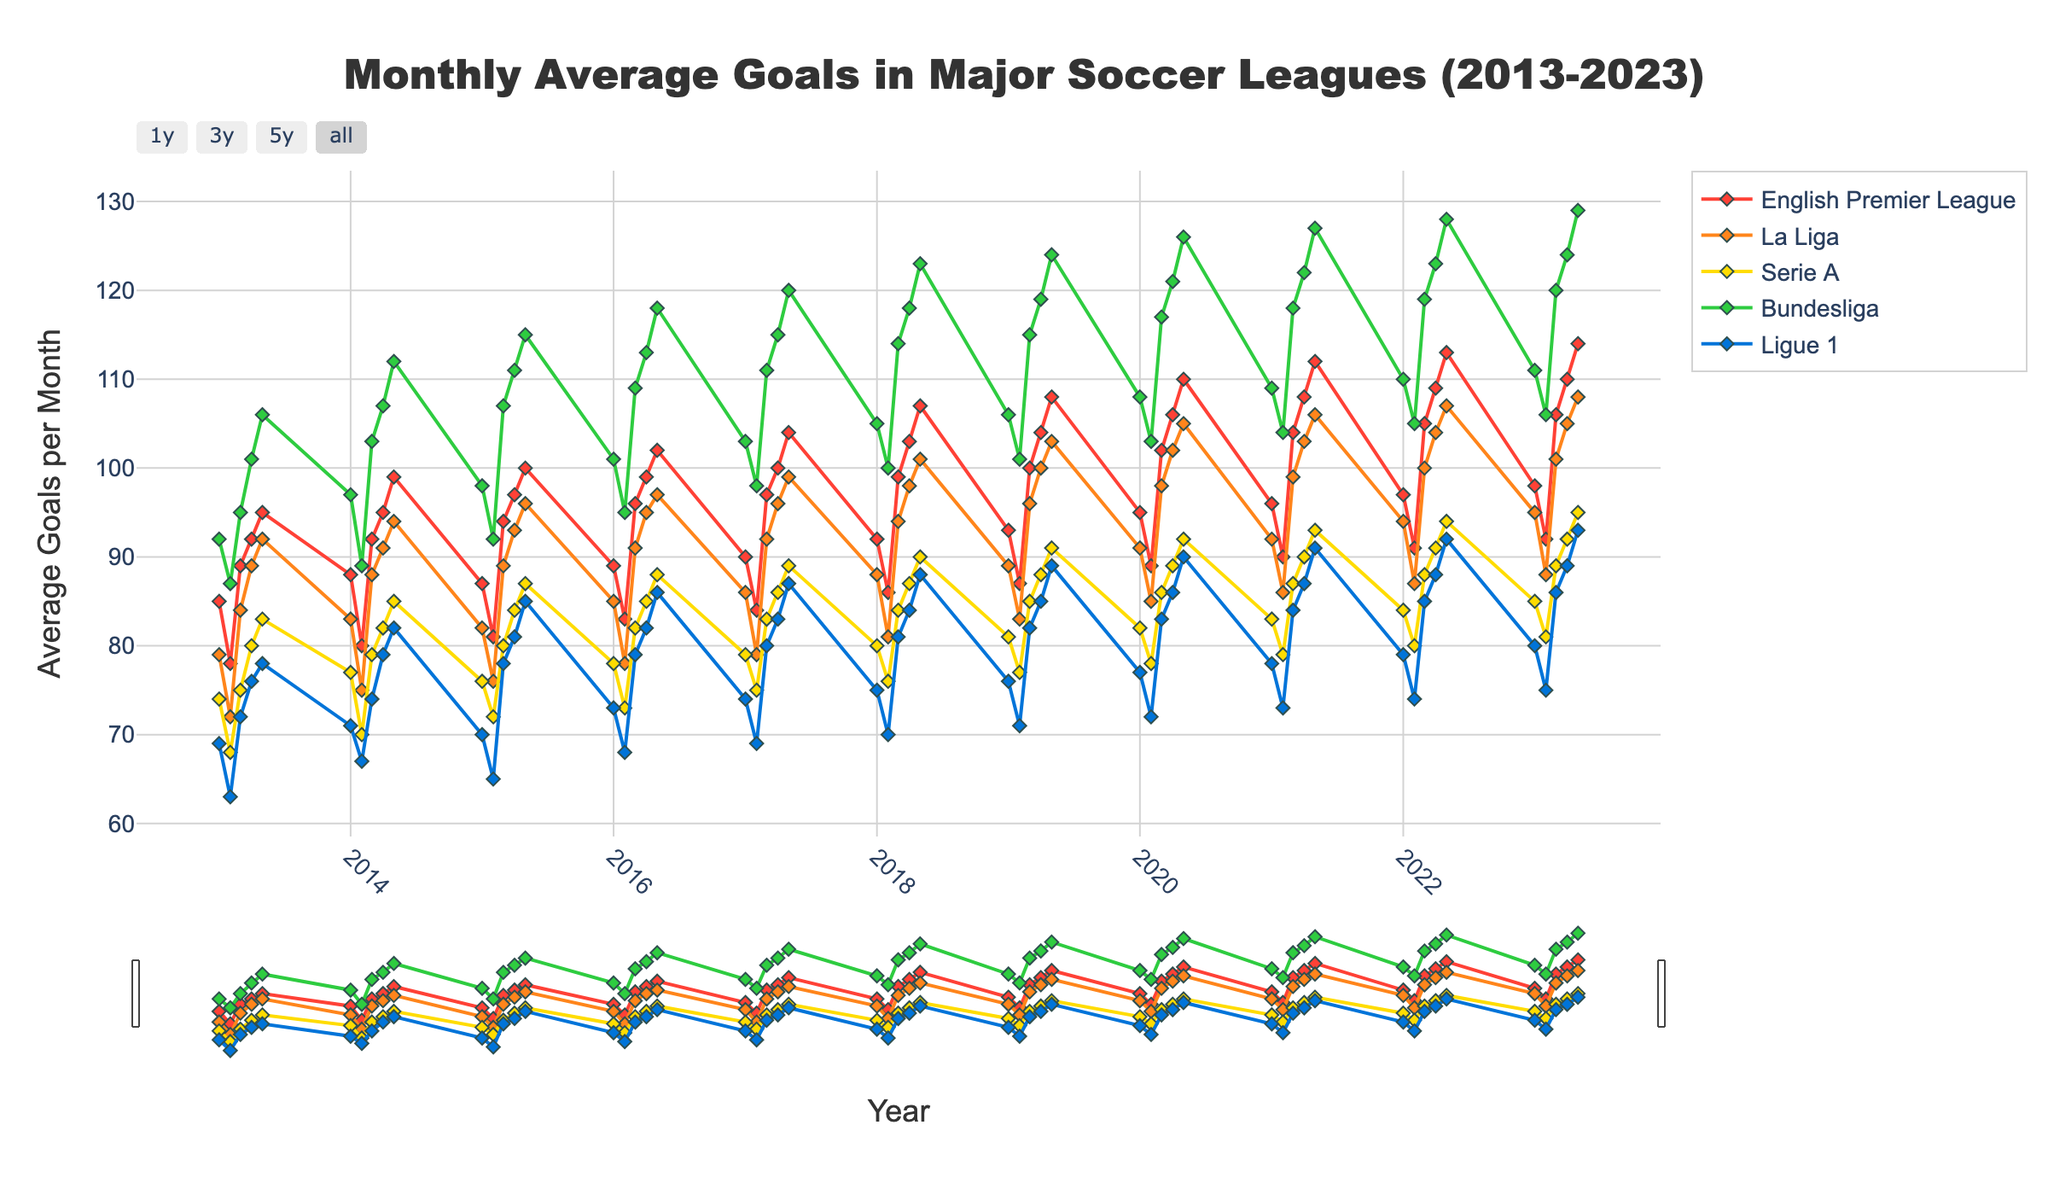What's the title of the plot? The title is displayed at the top center of the plot. It indicates the main subject of the data depicted.
Answer: Monthly Average Goals in Major Soccer Leagues (2013-2023) Which league had the highest average goals in May 2023? Look at the graph for the data points on May 2023 and compare the y-values of all leagues. The highest point belongs to the league with the highest average goals.
Answer: Bundesliga How many leagues are presented in the plot? Count the number of distinct lines or markers representing different leagues in the legend on the plot.
Answer: 5 During which month and year did Ligue 1 have the lowest average goal score? Trace the line representing Ligue 1 and identify the data point with the lowest y-value. Note the corresponding time on the x-axis.
Answer: February 2013 Between 2018 and 2020, how did the goal averages for Serie A change? Look at the data points from January 2018 to December 2020 for Serie A, noting the general trend or any significant changes.
Answer: Increased Which league displayed the most consistent average goal trend over the decade? Analyze the plot for the league whose line appears most stable without large fluctuations across the timeline.
Answer: Bundesliga Compare the goal averages of La Liga and the English Premier League in January 2022. Which had more goals and by what margin? Find the data points for La Liga and the English Premier League in January 2022 and subtract the smaller value from the larger one.
Answer: English Premier League by 3 goals What is the general trend of goals scored in all leagues from 2013 to 2023? Identify whether the lines generally move upwards, downwards, or remain consistent over the time span in the plot.
Answer: Upward By how much did the average goals in the Bundesliga increase from 2013 to 2023? Locate the data points for the Bundesliga in January 2013 and January 2023, then subtract the earlier value from the latter.
Answer: 19 goals 